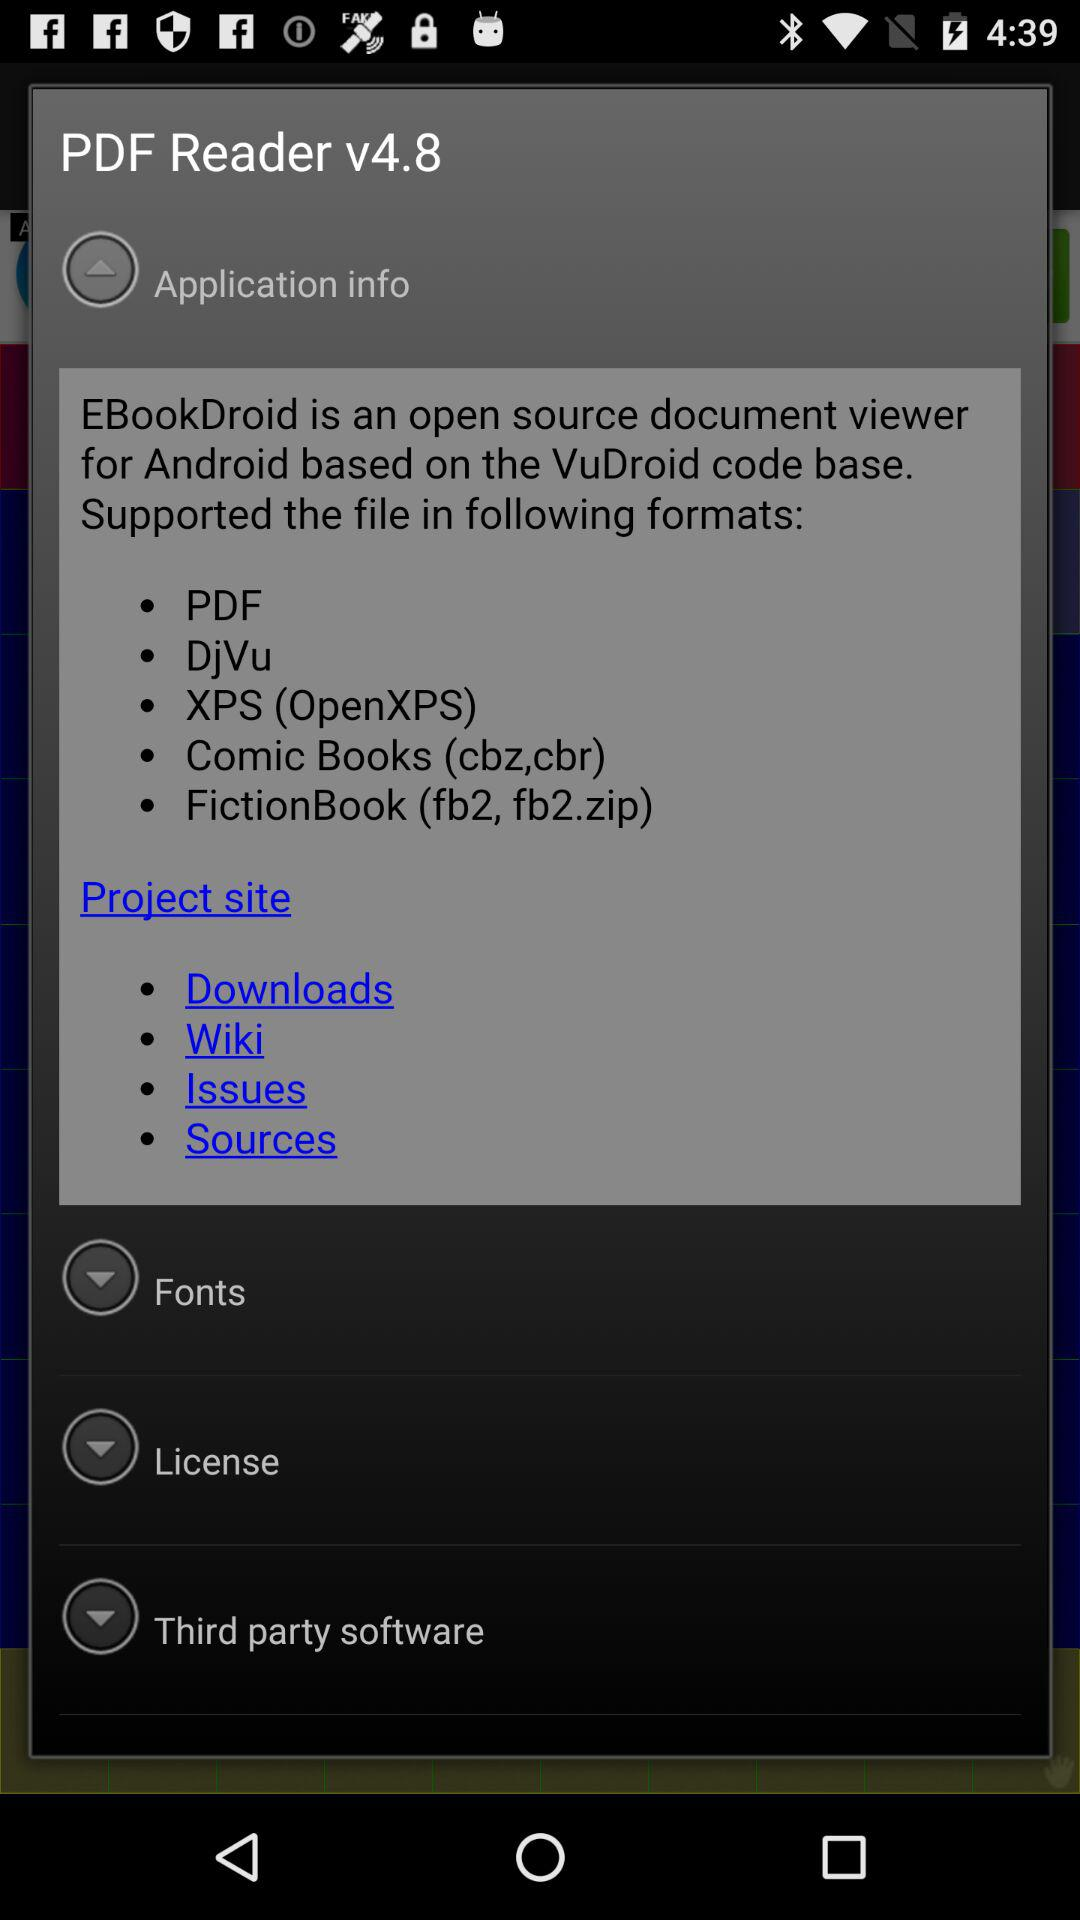How many supported formats are mentioned?
Answer the question using a single word or phrase. 5 